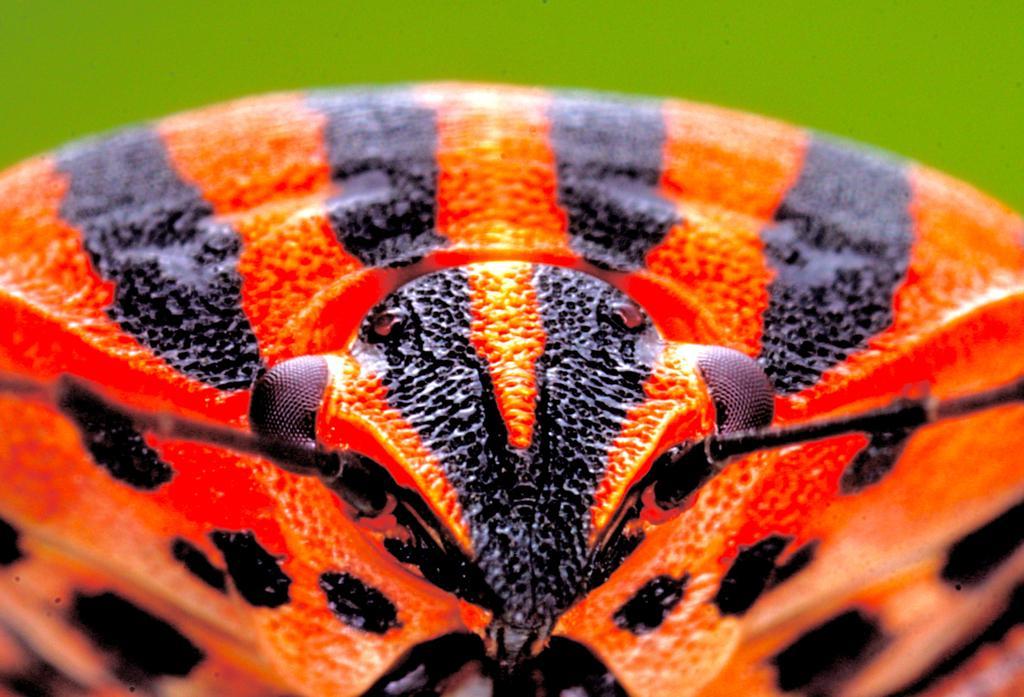Can you describe this image briefly? This is a macro image of an insect which is in red and black color. 